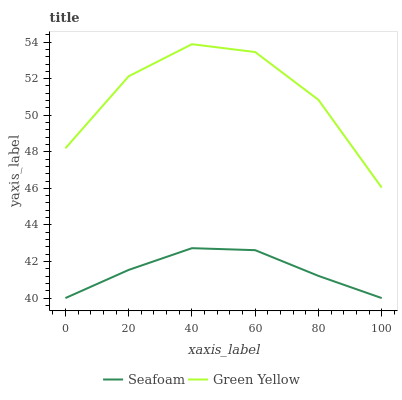Does Seafoam have the minimum area under the curve?
Answer yes or no. Yes. Does Green Yellow have the maximum area under the curve?
Answer yes or no. Yes. Does Seafoam have the maximum area under the curve?
Answer yes or no. No. Is Seafoam the smoothest?
Answer yes or no. Yes. Is Green Yellow the roughest?
Answer yes or no. Yes. Is Seafoam the roughest?
Answer yes or no. No. Does Green Yellow have the highest value?
Answer yes or no. Yes. Does Seafoam have the highest value?
Answer yes or no. No. Is Seafoam less than Green Yellow?
Answer yes or no. Yes. Is Green Yellow greater than Seafoam?
Answer yes or no. Yes. Does Seafoam intersect Green Yellow?
Answer yes or no. No. 